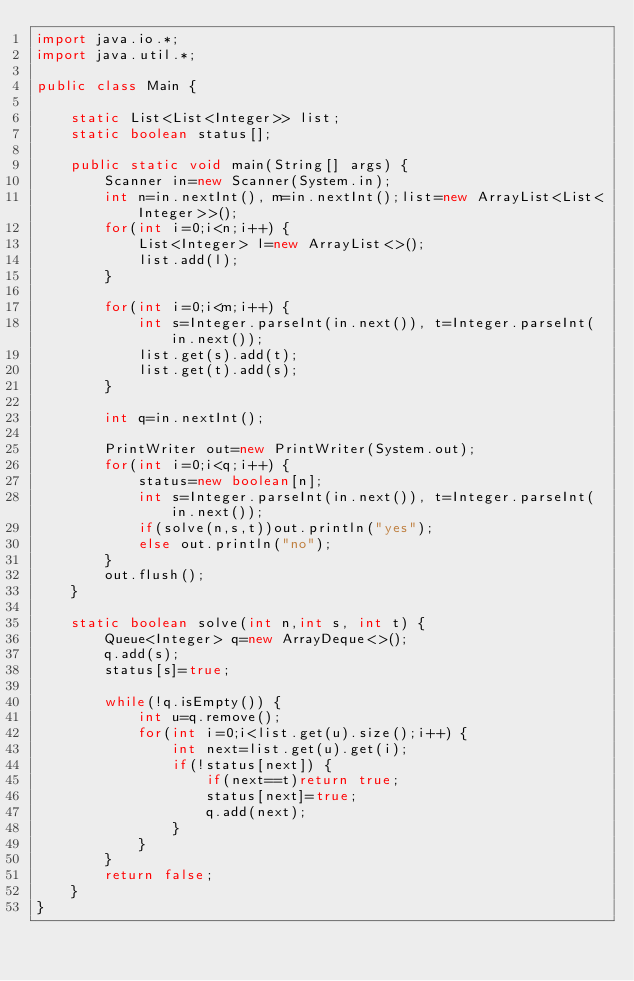<code> <loc_0><loc_0><loc_500><loc_500><_Java_>import java.io.*;
import java.util.*;

public class Main {
	
	static List<List<Integer>> list;
	static boolean status[];
	
	public static void main(String[] args) {
		Scanner in=new Scanner(System.in);
		int n=in.nextInt(), m=in.nextInt();list=new ArrayList<List<Integer>>();
		for(int i=0;i<n;i++) {
			List<Integer> l=new ArrayList<>();
			list.add(l);
		}
		
		for(int i=0;i<m;i++) {
			int s=Integer.parseInt(in.next()), t=Integer.parseInt(in.next());
			list.get(s).add(t);
			list.get(t).add(s);
		}
		
		int q=in.nextInt();
		
		PrintWriter out=new PrintWriter(System.out);
		for(int i=0;i<q;i++) {
			status=new boolean[n];
			int s=Integer.parseInt(in.next()), t=Integer.parseInt(in.next());
			if(solve(n,s,t))out.println("yes");
			else out.println("no");
		}
		out.flush();
	}
	
	static boolean solve(int n,int s, int t) {
		Queue<Integer> q=new ArrayDeque<>();
		q.add(s);
		status[s]=true;
		
		while(!q.isEmpty()) {
			int u=q.remove();
			for(int i=0;i<list.get(u).size();i++) {
				int next=list.get(u).get(i);
				if(!status[next]) {
					if(next==t)return true;
					status[next]=true;
					q.add(next);
				}
			}
		}
		return false;
	}
}

</code> 